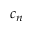Convert formula to latex. <formula><loc_0><loc_0><loc_500><loc_500>c _ { n }</formula> 